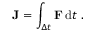<formula> <loc_0><loc_0><loc_500><loc_500>J = \int _ { \Delta t } F \, d t .</formula> 